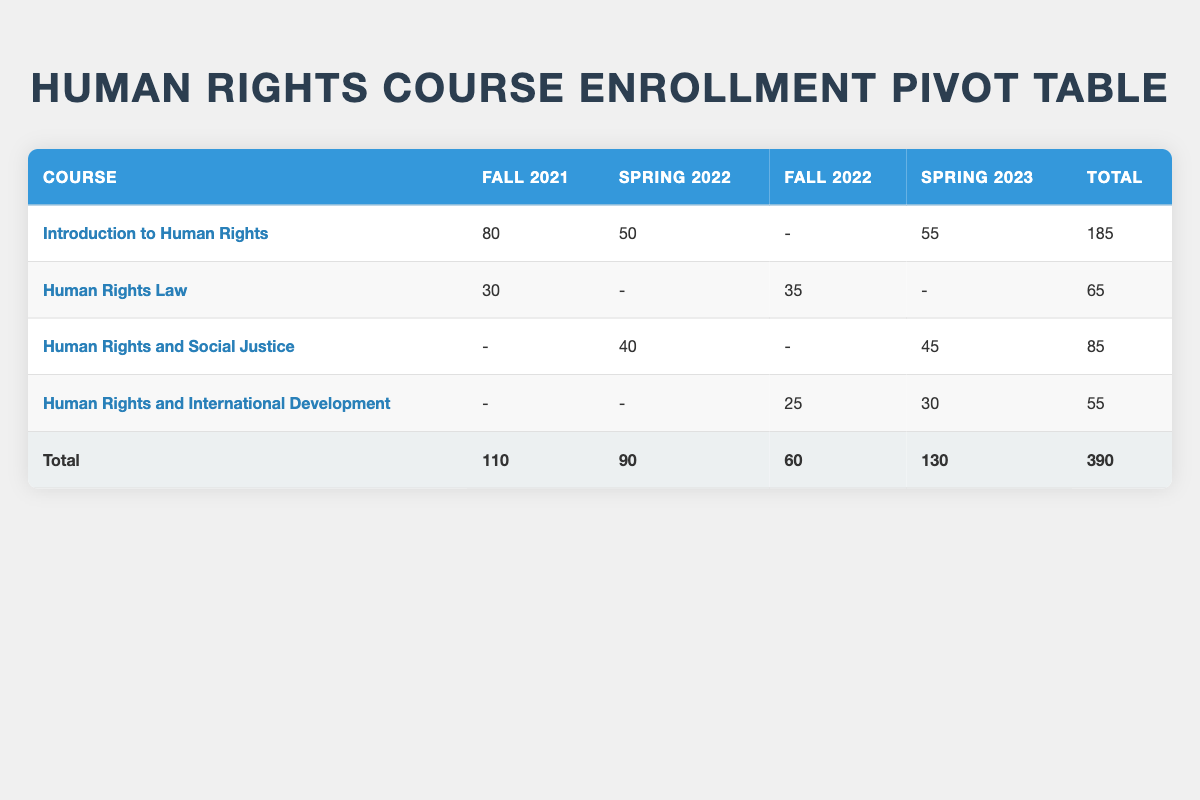What is the total enrollment for the course "Introduction to Human Rights"? Looking at the row for "Introduction to Human Rights," the total enrollment values across semesters are Fall 2021 (80), Spring 2022 (50), and Spring 2023 (55). In Fall 2022, enrollment is zero as no data is listed. Adding these together gives 80 + 50 + 0 + 55 = 185
Answer: 185 Which course had the highest enrollment in Spring 2023? In Spring 2023, the enrollment numbers are: "Introduction to Human Rights" (55), "Human Rights and Social Justice" (45), and "Human Rights and International Development" (30). Comparing these, "Introduction to Human Rights" has the highest enrollment at 55.
Answer: Introduction to Human Rights Is the total enrollment for "Human Rights Law" more than 50? The total enrollment for "Human Rights Law" across the semesters is Fall 2021 (30), Fall 2022 (35), and no enrollment for Spring 2022 and Spring 2023. Adding 30 + 0 + 35 + 0 gives a total of 65. Since 65 is greater than 50, the answer is yes.
Answer: Yes How many students were enrolled in "Human Rights and Social Justice" across all semesters? The enrollment for "Human Rights and Social Justice" is as follows: Spring 2022 (40) and Spring 2023 (45), with no enrollment noted for Fall 2021 or Fall 2022. Adding 0 + 40 + 0 + 45 = 85 gives a total enrollment of 85.
Answer: 85 What is the difference in total enrollment between Fall 2021 and Spring 2023? From the total row, Fall 2021 enrollment is 110, and Spring 2023 enrollment is 130. To find the difference, subtract Fall 2021 from Spring 2023: 130 - 110 = 20.
Answer: 20 Which semester had the lowest total enrollment across all courses? The total enrollment per semester is as follows: Fall 2021 (110), Spring 2022 (90), Fall 2022 (60), and Spring 2023 (130). The lowest value here is Spring 2022 with 90 total enrollments.
Answer: Spring 2022 Is it true that "Human Rights and International Development" had more female enrollments than male enrollments? In the table, "Human Rights and International Development" has a male enrollment of 25 (Fall 2022) and 0 female enrollments listed. Thus, there are more male enrollments (25) than female enrollments (0), making this statement false.
Answer: No What is the average enrollment across all semesters for "Human Rights Law"? The enrollment values for "Human Rights Law" are: 30 (Fall 2021), 0 (Spring 2022), 35 (Fall 2022), and 0 (Spring 2023). To find the average, sum the values (30 + 0 + 35 + 0) = 65 and divide by the count of semesters (4), resulting in 65/4 = 16.25.
Answer: 16.25 